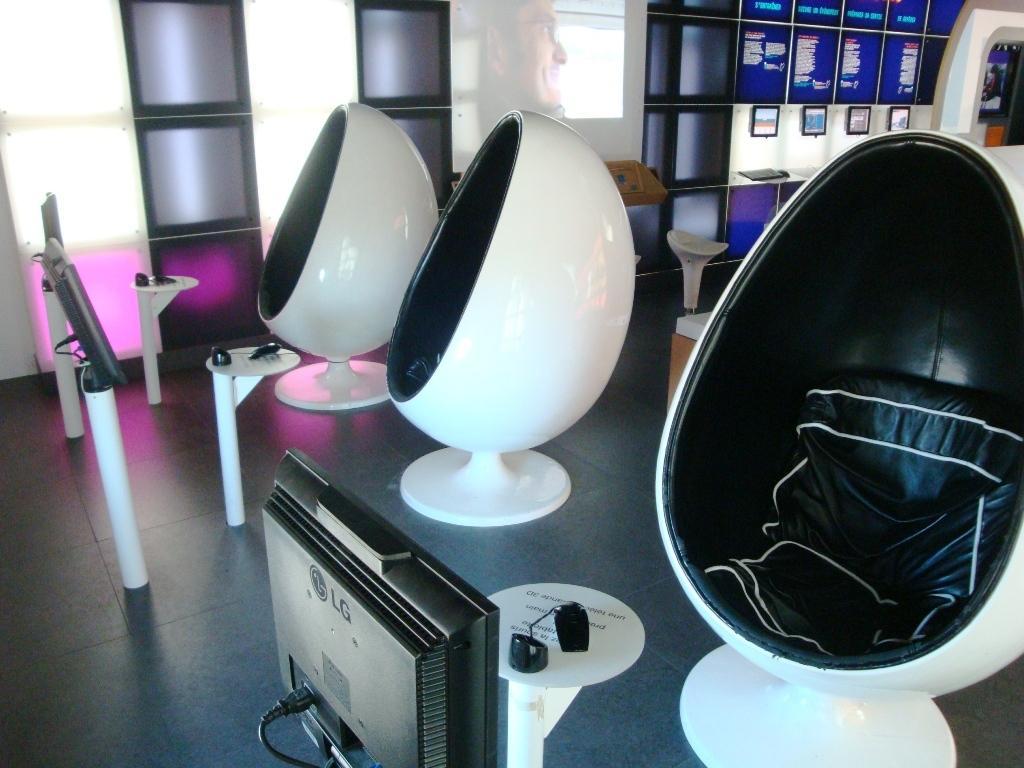Please provide a concise description of this image. In this image in the center there are objects which are white in colour and there is a monitor. In the background there is a screen and there are monitors on the wall and in front of the wall there are stands. 